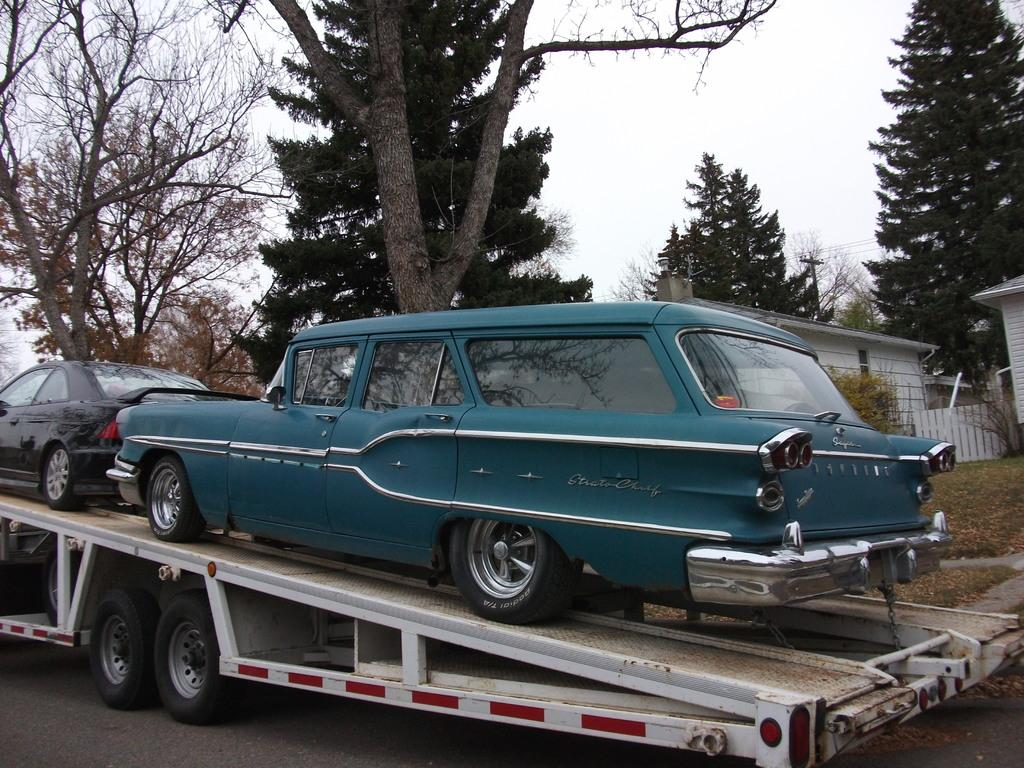What is the main subject of subject in the center of the image? There is a truck in the center of the image. What is on the truck? There are cars on the truck. What can be seen in the background of the image? There are trees and a house in the background of the image. What type of rake is being used to gather leaves in the image? There is no rake present in the image. 